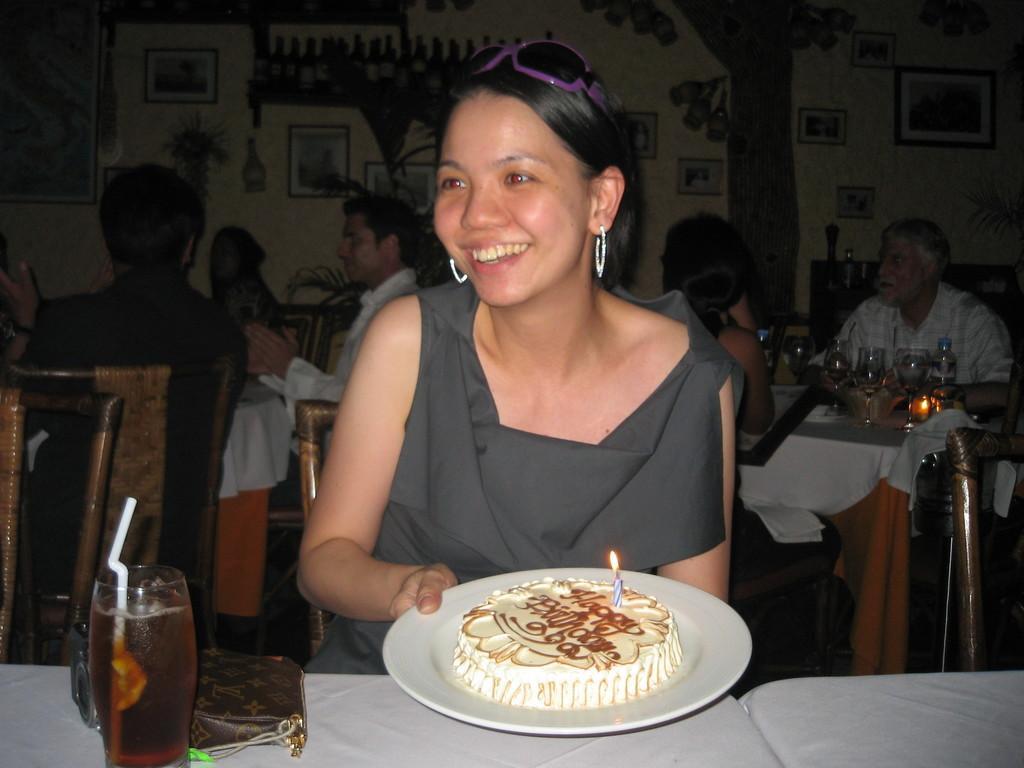Can you describe this image briefly? In this image, I can see a group of people are sitting on the chairs in front of tables, on which glasses, plates, bottles are there and one person is holding a plate in hand in which a cake is there. In the background, I can see wall paintings on a wall. This picture might be taken in a hotel. 